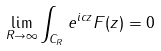<formula> <loc_0><loc_0><loc_500><loc_500>\lim _ { R \rightarrow \infty } \int _ { C _ { R } } e ^ { i c z } F ( z ) = 0</formula> 